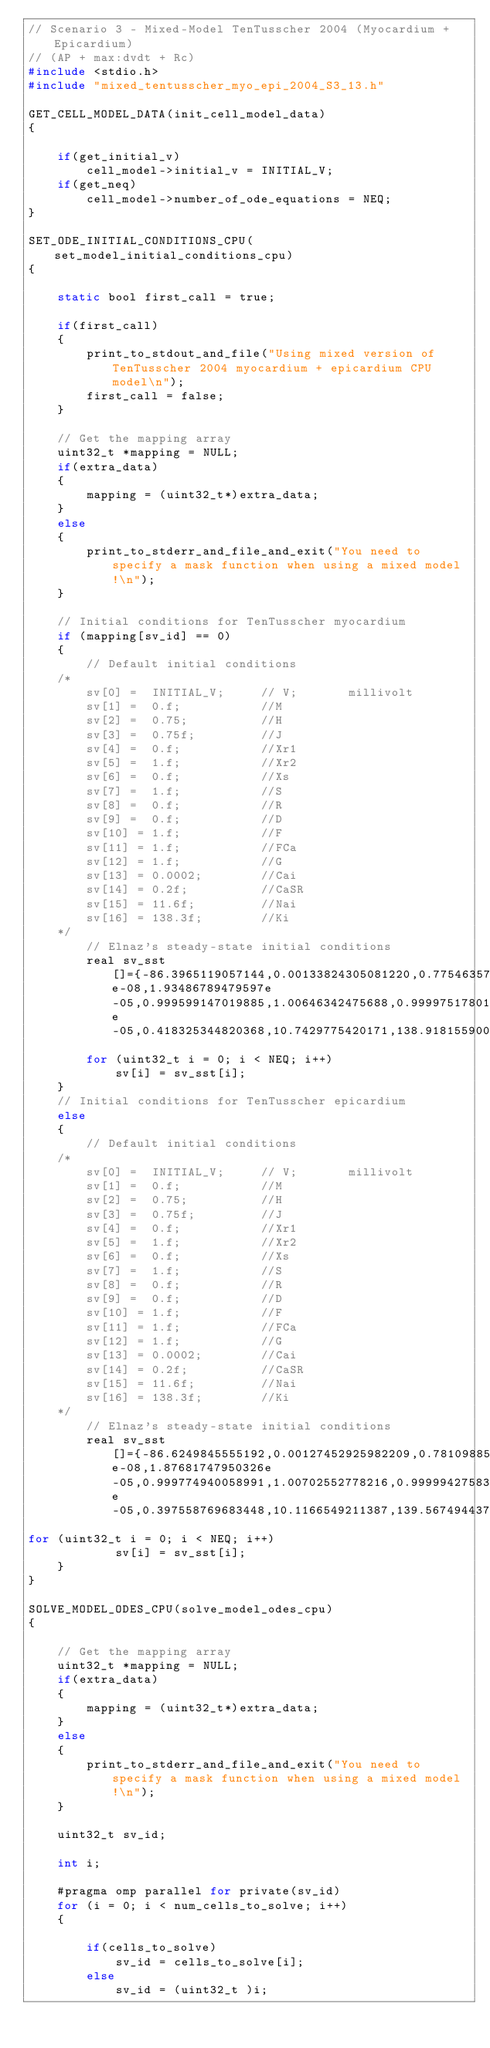Convert code to text. <code><loc_0><loc_0><loc_500><loc_500><_C_>// Scenario 3 - Mixed-Model TenTusscher 2004 (Myocardium + Epicardium)
// (AP + max:dvdt + Rc)
#include <stdio.h>
#include "mixed_tentusscher_myo_epi_2004_S3_13.h"

GET_CELL_MODEL_DATA(init_cell_model_data) 
{

    if(get_initial_v)
        cell_model->initial_v = INITIAL_V;
    if(get_neq)
        cell_model->number_of_ode_equations = NEQ;
}

SET_ODE_INITIAL_CONDITIONS_CPU(set_model_initial_conditions_cpu) 
{

    static bool first_call = true;

    if(first_call) 
    {
        print_to_stdout_and_file("Using mixed version of TenTusscher 2004 myocardium + epicardium CPU model\n");
        first_call = false;
    }
    
    // Get the mapping array
    uint32_t *mapping = NULL;
    if(extra_data) 
    {
        mapping = (uint32_t*)extra_data;
    }
    else 
    {
        print_to_stderr_and_file_and_exit("You need to specify a mask function when using a mixed model!\n");
    }

    // Initial conditions for TenTusscher myocardium
    if (mapping[sv_id] == 0)
    {
        // Default initial conditions
    /*
        sv[0] =  INITIAL_V;     // V;       millivolt
        sv[1] =  0.f;           //M
        sv[2] =  0.75;          //H
        sv[3] =  0.75f;         //J
        sv[4] =  0.f;           //Xr1
        sv[5] =  1.f;           //Xr2
        sv[6] =  0.f;           //Xs
        sv[7] =  1.f;           //S
        sv[8] =  0.f;           //R
        sv[9] =  0.f;           //D
        sv[10] = 1.f;           //F
        sv[11] = 1.f;           //FCa
        sv[12] = 1.f;           //G
        sv[13] = 0.0002;        //Cai
        sv[14] = 0.2f;          //CaSR
        sv[15] = 11.6f;         //Nai
        sv[16] = 138.3f;        //Ki
    */
        // Elnaz's steady-state initial conditions
        real sv_sst[]={-86.3965119057144,0.00133824305081220,0.775463576993407,0.775278393595599,0.000179499343643571,0.483303039835057,0.00297647859235379,0.999998290403642,1.98961879737287e-08,1.93486789479597e-05,0.999599147019885,1.00646342475688,0.999975178010127,5.97703651642618e-05,0.418325344820368,10.7429775420171,138.918155900633};
        for (uint32_t i = 0; i < NEQ; i++)
            sv[i] = sv_sst[i];
    }
    // Initial conditions for TenTusscher epicardium
    else
    {
        // Default initial conditions
    /*
        sv[0] =  INITIAL_V;     // V;       millivolt
        sv[1] =  0.f;           //M
        sv[2] =  0.75;          //H
        sv[3] =  0.75f;         //J
        sv[4] =  0.f;           //Xr1
        sv[5] =  1.f;           //Xr2
        sv[6] =  0.f;           //Xs
        sv[7] =  1.f;           //S
        sv[8] =  0.f;           //R
        sv[9] =  0.f;           //D
        sv[10] = 1.f;           //F
        sv[11] = 1.f;           //FCa
        sv[12] = 1.f;           //G
        sv[13] = 0.0002;        //Cai
        sv[14] = 0.2f;          //CaSR
        sv[15] = 11.6f;         //Nai
        sv[16] = 138.3f;        //Ki
    */
        // Elnaz's steady-state initial conditions
        real sv_sst[]={-86.6249845555192,0.00127452925982209,0.781098854878912,0.780945505139612,0.000173127258213963,0.485680542843999,0.00292844596868805,0.999998366997264,1.91530092199862e-08,1.87681747950326e-05,0.999774940058991,1.00702552778216,0.999994275830871,4.68103990785171e-05,0.397558769683448,10.1166549211387,139.567494437918};
for (uint32_t i = 0; i < NEQ; i++)
            sv[i] = sv_sst[i];
    }
}

SOLVE_MODEL_ODES_CPU(solve_model_odes_cpu) 
{

    // Get the mapping array
    uint32_t *mapping = NULL;
    if(extra_data) 
    {
        mapping = (uint32_t*)extra_data;
    }
    else 
    {
        print_to_stderr_and_file_and_exit("You need to specify a mask function when using a mixed model!\n");
    }

    uint32_t sv_id;

	int i;

    #pragma omp parallel for private(sv_id)
    for (i = 0; i < num_cells_to_solve; i++) 
    {

        if(cells_to_solve)
            sv_id = cells_to_solve[i];
        else
            sv_id = (uint32_t )i;
</code> 